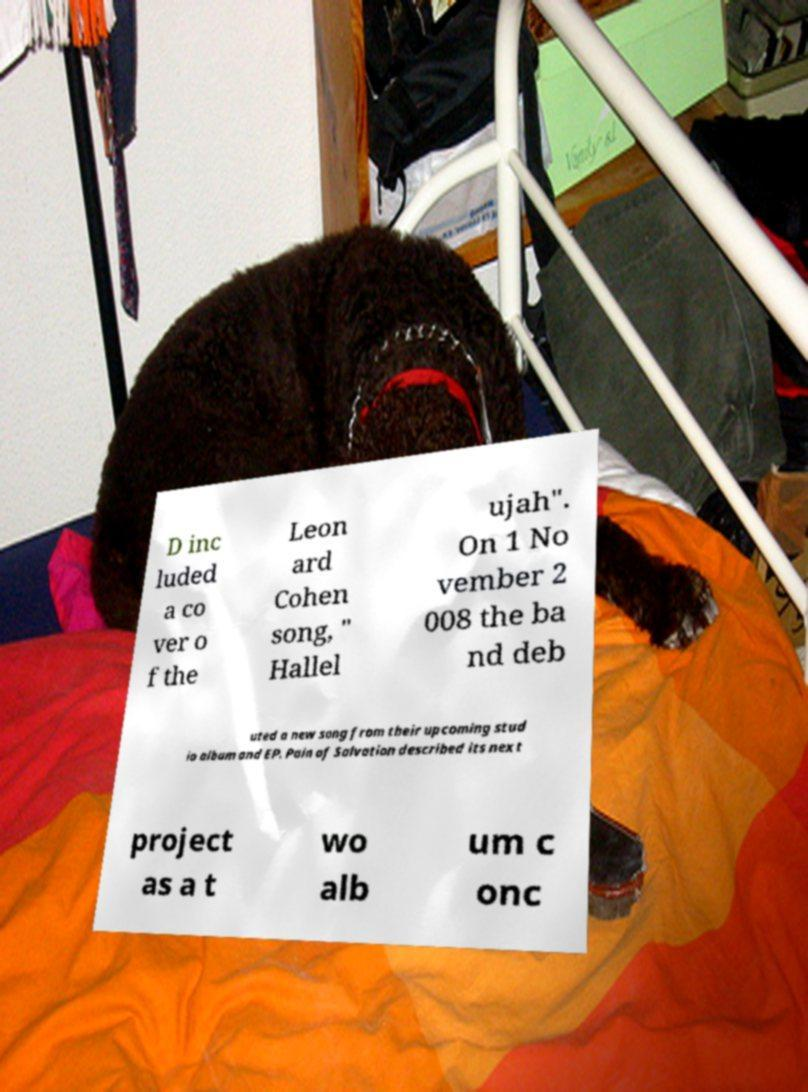What messages or text are displayed in this image? I need them in a readable, typed format. D inc luded a co ver o f the Leon ard Cohen song, " Hallel ujah". On 1 No vember 2 008 the ba nd deb uted a new song from their upcoming stud io album and EP. Pain of Salvation described its next project as a t wo alb um c onc 